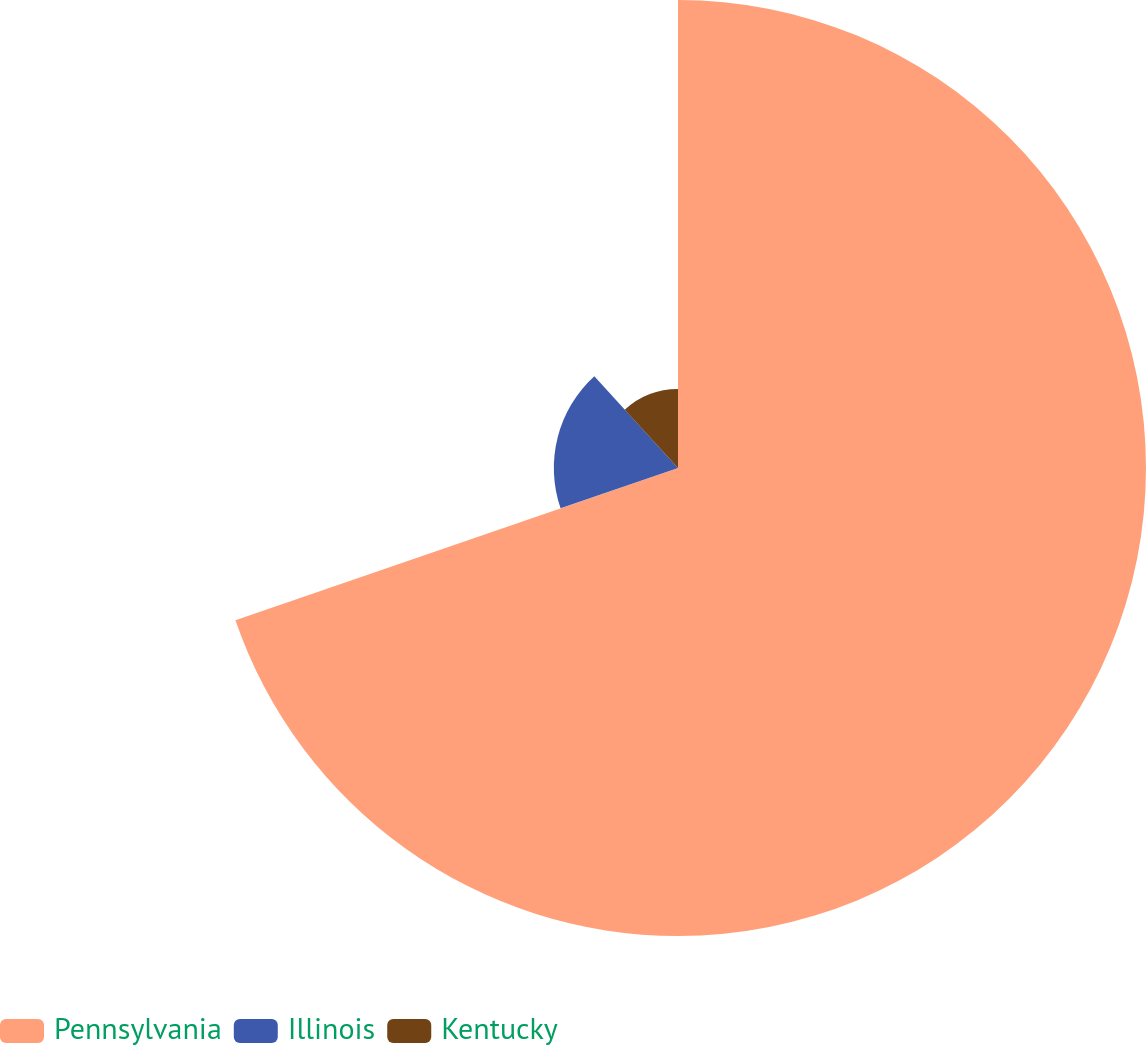<chart> <loc_0><loc_0><loc_500><loc_500><pie_chart><fcel>Pennsylvania<fcel>Illinois<fcel>Kentucky<nl><fcel>69.73%<fcel>18.5%<fcel>11.77%<nl></chart> 